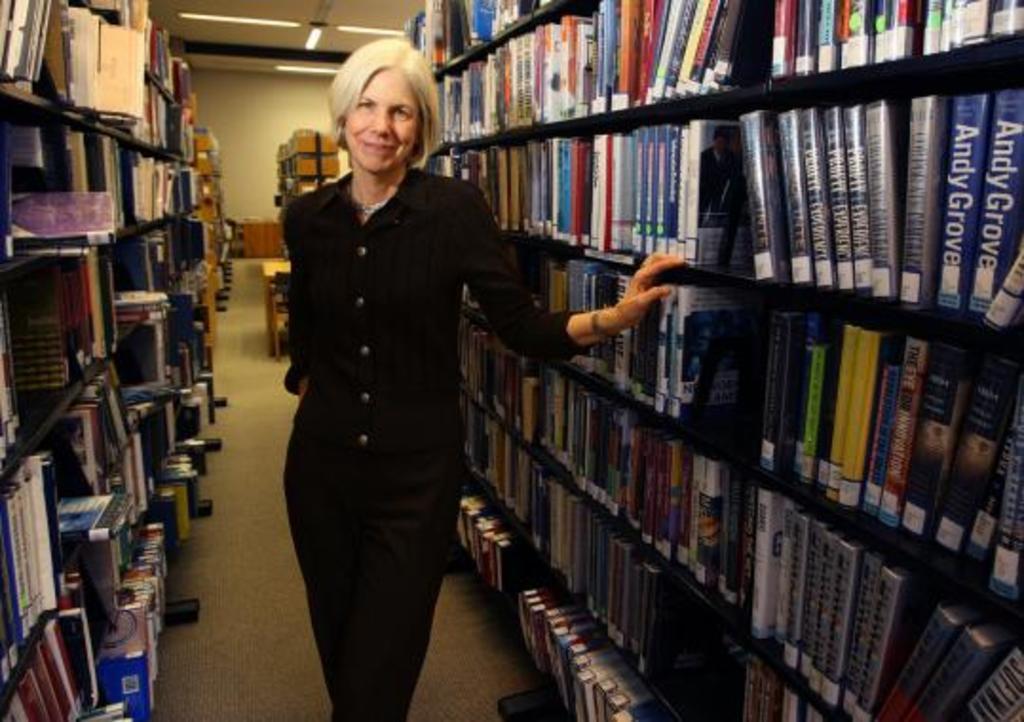Where is she at?
Keep it short and to the point. Answering does not require reading text in the image. 